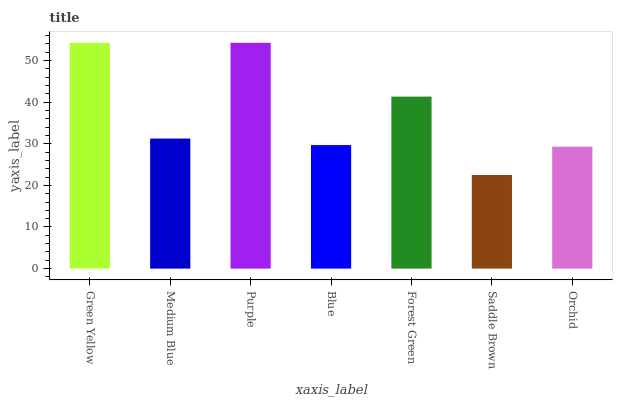Is Saddle Brown the minimum?
Answer yes or no. Yes. Is Purple the maximum?
Answer yes or no. Yes. Is Medium Blue the minimum?
Answer yes or no. No. Is Medium Blue the maximum?
Answer yes or no. No. Is Green Yellow greater than Medium Blue?
Answer yes or no. Yes. Is Medium Blue less than Green Yellow?
Answer yes or no. Yes. Is Medium Blue greater than Green Yellow?
Answer yes or no. No. Is Green Yellow less than Medium Blue?
Answer yes or no. No. Is Medium Blue the high median?
Answer yes or no. Yes. Is Medium Blue the low median?
Answer yes or no. Yes. Is Saddle Brown the high median?
Answer yes or no. No. Is Saddle Brown the low median?
Answer yes or no. No. 